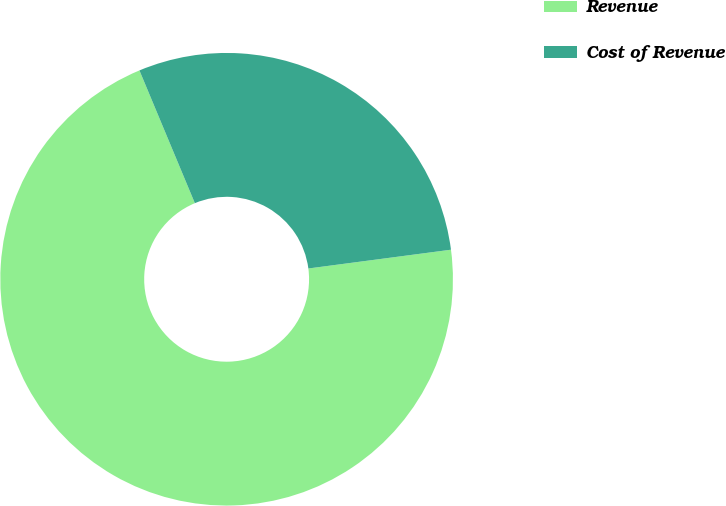<chart> <loc_0><loc_0><loc_500><loc_500><pie_chart><fcel>Revenue<fcel>Cost of Revenue<nl><fcel>70.79%<fcel>29.21%<nl></chart> 